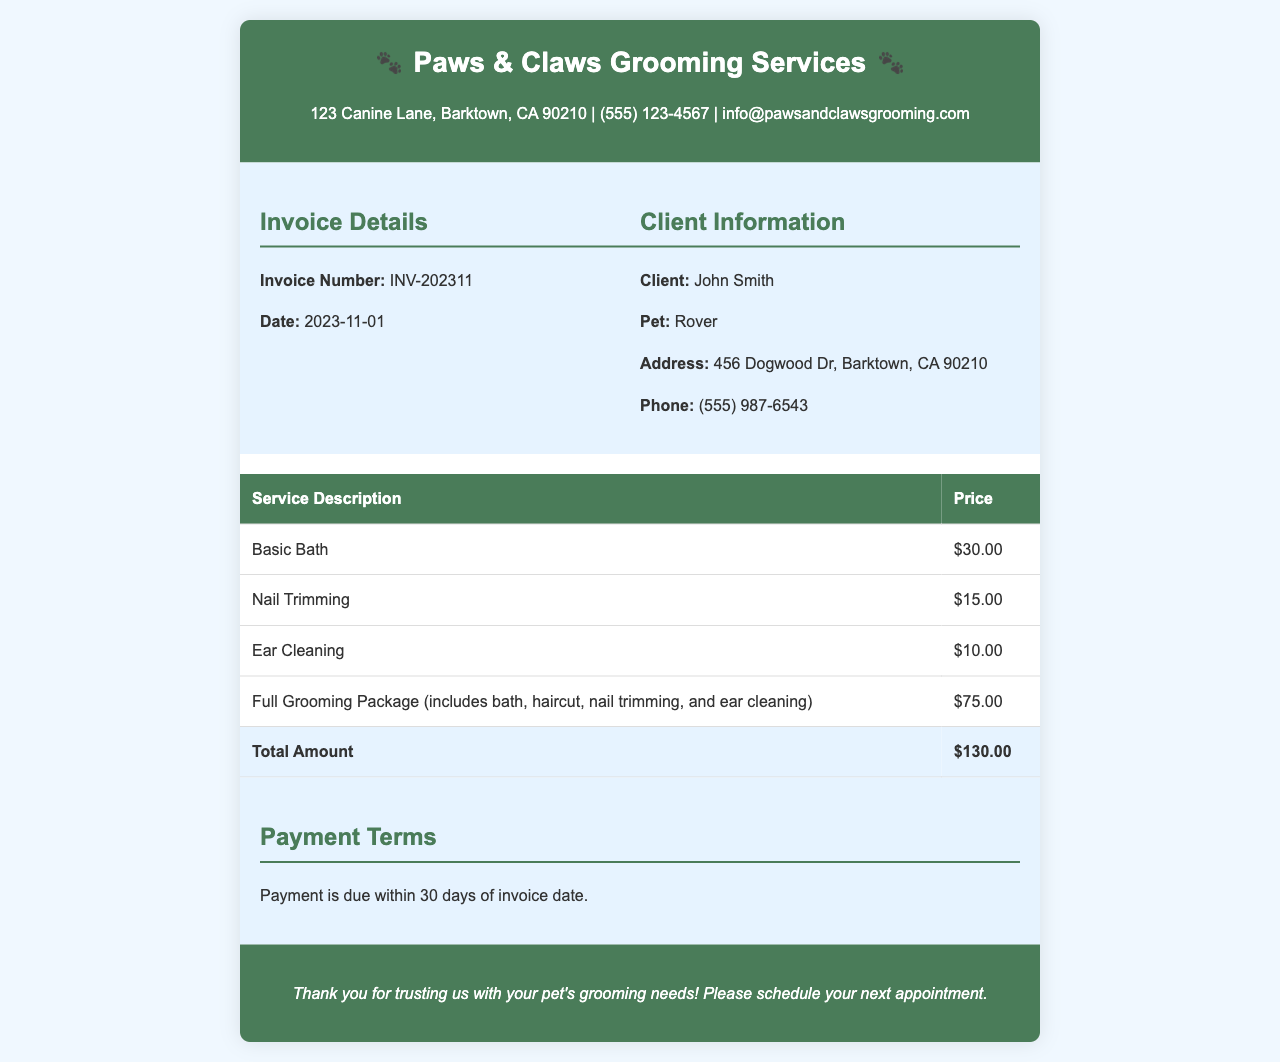What is the invoice number? The invoice number is listed under the Invoice Details section as INV-202311.
Answer: INV-202311 What is the date of the invoice? The date is specified under the Invoice Details section, which is 2023-11-01.
Answer: 2023-11-01 Who is the client? The client’s name is provided in the Client Information section as John Smith.
Answer: John Smith How much does the Full Grooming Package cost? The price for the Full Grooming Package is listed in the services table as $75.00.
Answer: $75.00 What is the total amount due? The total amount due is the sum of all services rendered, shown in the services table.
Answer: $130.00 How many services are listed in the invoice? The number of services can be counted from the services table, which contains four entries.
Answer: 4 What is the payment term? The payment term specifies that payment is due within 30 days of the invoice date.
Answer: 30 days What is the address of the grooming service? The address is provided in the header of the document as 123 Canine Lane, Barktown, CA 90210.
Answer: 123 Canine Lane, Barktown, CA 90210 What is the phone number of the grooming service? The phone number is listed in the header as (555) 123-4567.
Answer: (555) 123-4567 